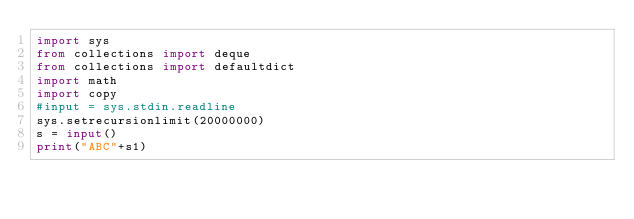<code> <loc_0><loc_0><loc_500><loc_500><_Python_>import sys
from collections import deque
from collections import defaultdict
import math
import copy
#input = sys.stdin.readline
sys.setrecursionlimit(20000000)
s = input()
print("ABC"+s1)</code> 